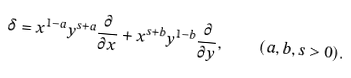Convert formula to latex. <formula><loc_0><loc_0><loc_500><loc_500>\delta = x ^ { 1 - a } y ^ { s + a } \frac { \partial } { \partial x } + x ^ { s + b } y ^ { 1 - b } \frac { \partial } { \partial y } , \quad ( a , b , s > 0 ) .</formula> 